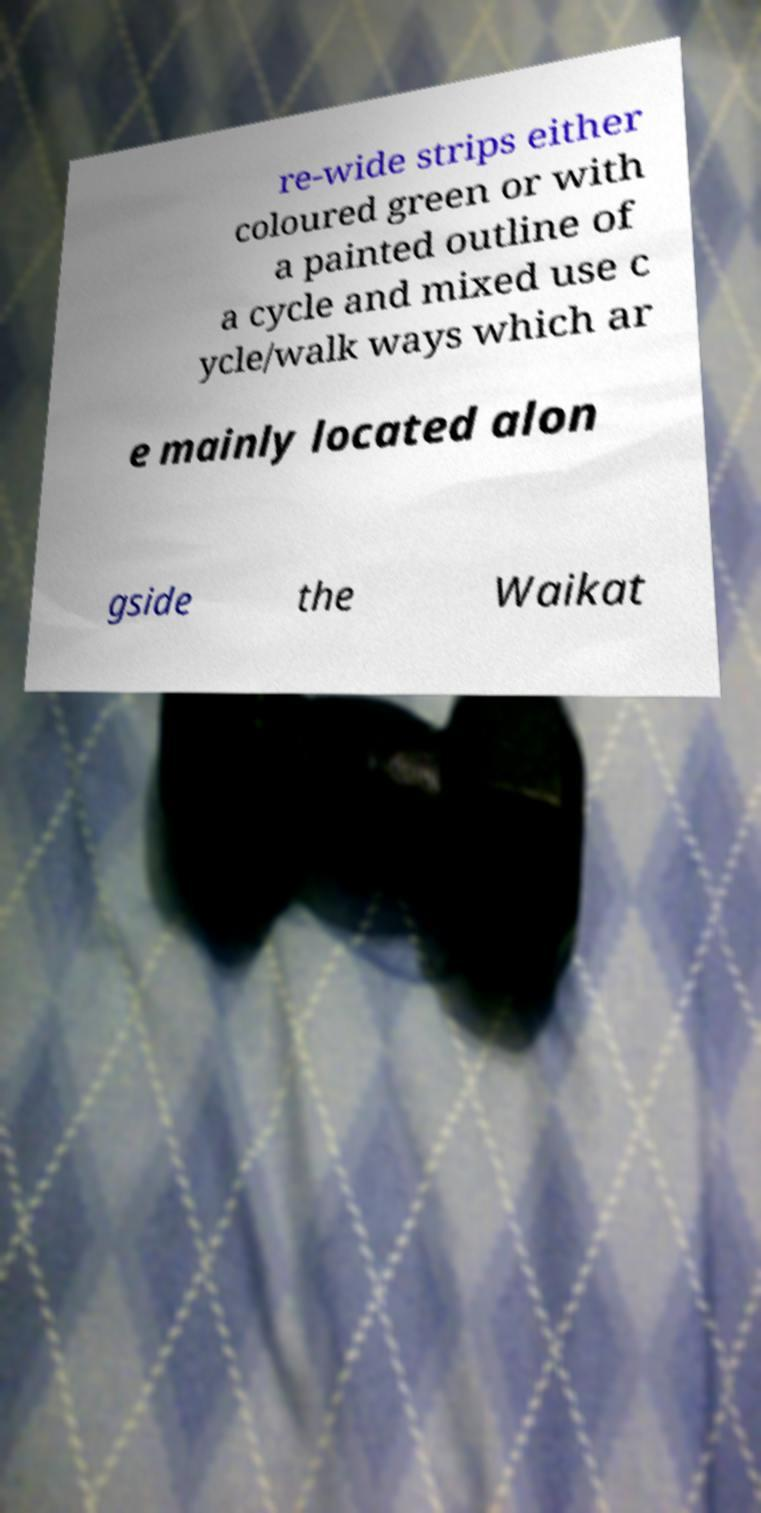Could you assist in decoding the text presented in this image and type it out clearly? re-wide strips either coloured green or with a painted outline of a cycle and mixed use c ycle/walk ways which ar e mainly located alon gside the Waikat 